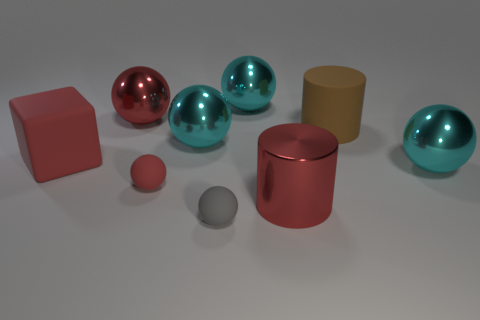What size is the cube? The cube appears to be medium-sized in relation to the other objects present in the image, such as the spheres and cylinders. 